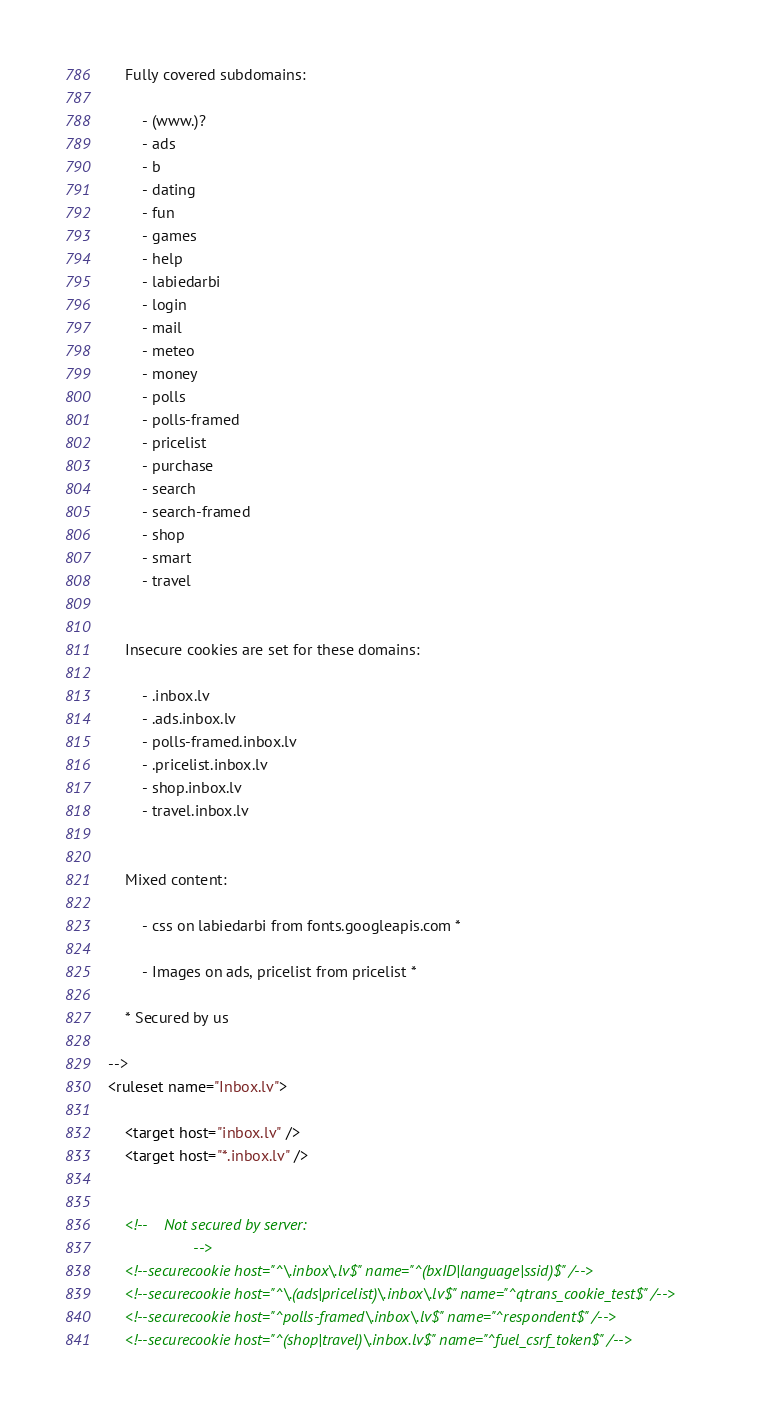Convert code to text. <code><loc_0><loc_0><loc_500><loc_500><_XML_>	Fully covered subdomains:

		- (www.)?
		- ads
		- b
		- dating
		- fun
		- games
		- help
		- labiedarbi
		- login
		- mail
		- meteo
		- money
		- polls
		- polls-framed
		- pricelist
		- purchase
		- search
		- search-framed
		- shop
		- smart
		- travel


	Insecure cookies are set for these domains:

		- .inbox.lv
		- .ads.inbox.lv
		- polls-framed.inbox.lv
		- .pricelist.inbox.lv
		- shop.inbox.lv
		- travel.inbox.lv


	Mixed content:

		- css on labiedarbi from fonts.googleapis.com *

		- Images on ads, pricelist from pricelist *

	* Secured by us

-->
<ruleset name="Inbox.lv">

	<target host="inbox.lv" />
	<target host="*.inbox.lv" />


	<!--	Not secured by server:
					-->
	<!--securecookie host="^\.inbox\.lv$" name="^(bxID|language|ssid)$" /-->
	<!--securecookie host="^\.(ads|pricelist)\.inbox\.lv$" name="^qtrans_cookie_test$" /-->
	<!--securecookie host="^polls-framed\.inbox\.lv$" name="^respondent$" /-->
	<!--securecookie host="^(shop|travel)\.inbox.lv$" name="^fuel_csrf_token$" /-->
</code> 